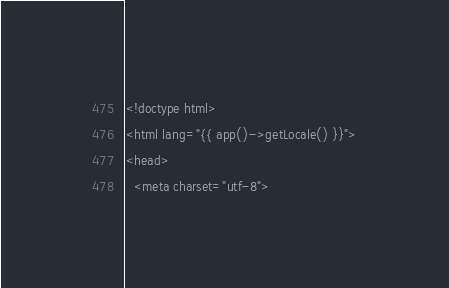<code> <loc_0><loc_0><loc_500><loc_500><_PHP_><!doctype html>
<html lang="{{ app()->getLocale() }}">
<head>
  <meta charset="utf-8"></code> 